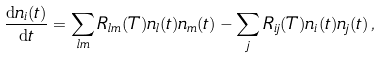Convert formula to latex. <formula><loc_0><loc_0><loc_500><loc_500>\frac { \mathrm d n _ { i } ( t ) } { \mathrm d t } = \sum _ { l m } R _ { l m } ( T ) n _ { l } ( t ) n _ { m } ( t ) - \sum _ { j } R _ { i j } ( T ) n _ { i } ( t ) n _ { j } ( t ) \, ,</formula> 